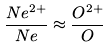Convert formula to latex. <formula><loc_0><loc_0><loc_500><loc_500>\frac { N e ^ { 2 + } } { N e } \approx \frac { O ^ { 2 + } } { O }</formula> 